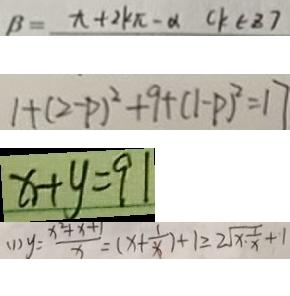<formula> <loc_0><loc_0><loc_500><loc_500>\beta = x + 2 k \pi - \alpha C k \in 8 7 
 1 + ( 2 - p ) ^ { 2 } + 9 + ( 1 - p ) ^ { 2 } = 1 7 
 x + y = 9 1 
 ( 1 ) y = \frac { x ^ { 2 } + x + 1 } { x } = ( x + \frac { 1 } { x } ) + 1 \geq 2 \sqrt { x \cdot \frac { 1 } { x } } + 1</formula> 